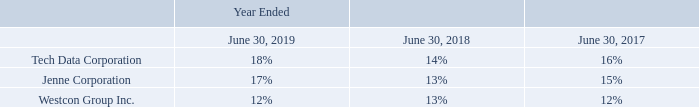Concentrations
The Company may be subject to concentration of credit risk as a result of certain financial instruments consisting of accounts receivable and short term investments. The Company performs ongoing credit evaluations of its customers and generally does not require collateral in exchange for credit.
The following table sets forth major customers accounting for 10% or more of the Company’s net revenue:
Why does the company not require collateral in exchange for credit generally? The company performs ongoing credit evaluations of its customers. What was the percentage of net revenue occupied by Tech Data Corporation in 2017?
Answer scale should be: percent. 16. Which years does the table provide information for major customers accounting for 10% or more of the Company’s net revenue? 2019, 2018, 2017. How many companies accounted for more than 15% of the company's net revenue in 2019? Tech Data Corporation##Jenne Corporation
Answer: 2. What was the change in the percentage that Tech Data Corporation accounted for between 2018 and 2019?
Answer scale should be: percent. 18-14
Answer: 4. How much did all three companies account for in the company's net revenue in 2017?
Answer scale should be: percent. 16+15+12
Answer: 43. 